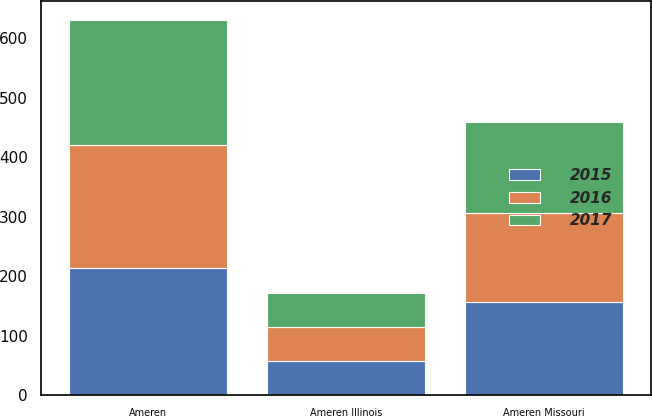Convert chart. <chart><loc_0><loc_0><loc_500><loc_500><stacked_bar_chart><ecel><fcel>Ameren Missouri<fcel>Ameren Illinois<fcel>Ameren<nl><fcel>2017<fcel>153<fcel>57<fcel>210<nl><fcel>2016<fcel>151<fcel>57<fcel>208<nl><fcel>2015<fcel>156<fcel>57<fcel>213<nl></chart> 